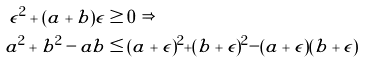Convert formula to latex. <formula><loc_0><loc_0><loc_500><loc_500>\epsilon ^ { 2 } + ( a + b ) \epsilon & \geq 0 \text { } \Rightarrow \\ a ^ { 2 } + b ^ { 2 } - a b & \leq ( a + \epsilon ) ^ { 2 } + ( b + \epsilon ) ^ { 2 } - ( a + \epsilon ) ( b + \epsilon )</formula> 